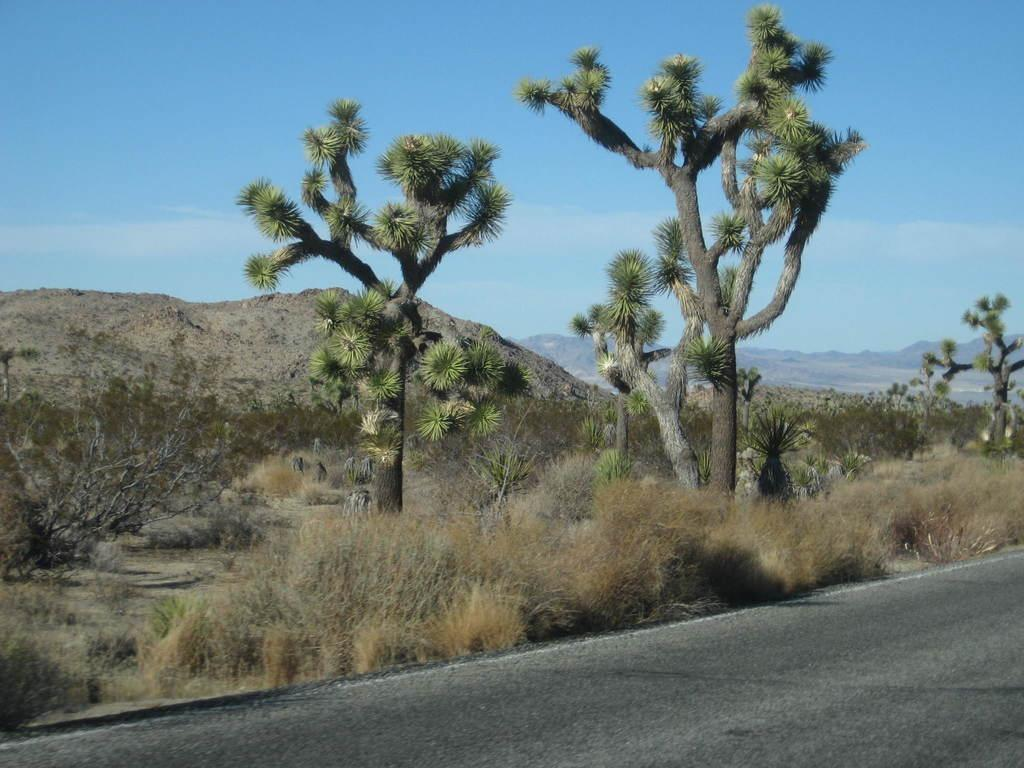What type of vegetation can be seen in the image? There are plants, grass, and trees in the image. What type of surface is visible in the image? There is a road in the image. What can be seen in the background of the image? The sky is visible in the background of the image. Where is the library located in the image? There is no library present in the image. What is the edge of the image like? The edge of the image is not visible in the image itself, as it is a two-dimensional representation. 